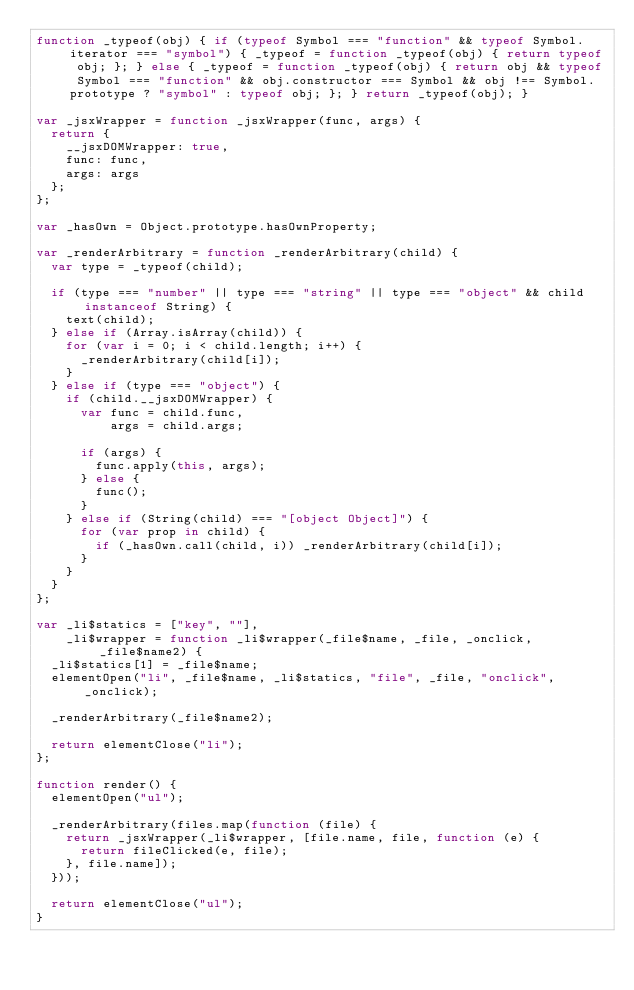Convert code to text. <code><loc_0><loc_0><loc_500><loc_500><_JavaScript_>function _typeof(obj) { if (typeof Symbol === "function" && typeof Symbol.iterator === "symbol") { _typeof = function _typeof(obj) { return typeof obj; }; } else { _typeof = function _typeof(obj) { return obj && typeof Symbol === "function" && obj.constructor === Symbol && obj !== Symbol.prototype ? "symbol" : typeof obj; }; } return _typeof(obj); }

var _jsxWrapper = function _jsxWrapper(func, args) {
  return {
    __jsxDOMWrapper: true,
    func: func,
    args: args
  };
};

var _hasOwn = Object.prototype.hasOwnProperty;

var _renderArbitrary = function _renderArbitrary(child) {
  var type = _typeof(child);

  if (type === "number" || type === "string" || type === "object" && child instanceof String) {
    text(child);
  } else if (Array.isArray(child)) {
    for (var i = 0; i < child.length; i++) {
      _renderArbitrary(child[i]);
    }
  } else if (type === "object") {
    if (child.__jsxDOMWrapper) {
      var func = child.func,
          args = child.args;

      if (args) {
        func.apply(this, args);
      } else {
        func();
      }
    } else if (String(child) === "[object Object]") {
      for (var prop in child) {
        if (_hasOwn.call(child, i)) _renderArbitrary(child[i]);
      }
    }
  }
};

var _li$statics = ["key", ""],
    _li$wrapper = function _li$wrapper(_file$name, _file, _onclick, _file$name2) {
  _li$statics[1] = _file$name;
  elementOpen("li", _file$name, _li$statics, "file", _file, "onclick", _onclick);

  _renderArbitrary(_file$name2);

  return elementClose("li");
};

function render() {
  elementOpen("ul");

  _renderArbitrary(files.map(function (file) {
    return _jsxWrapper(_li$wrapper, [file.name, file, function (e) {
      return fileClicked(e, file);
    }, file.name]);
  }));

  return elementClose("ul");
}</code> 